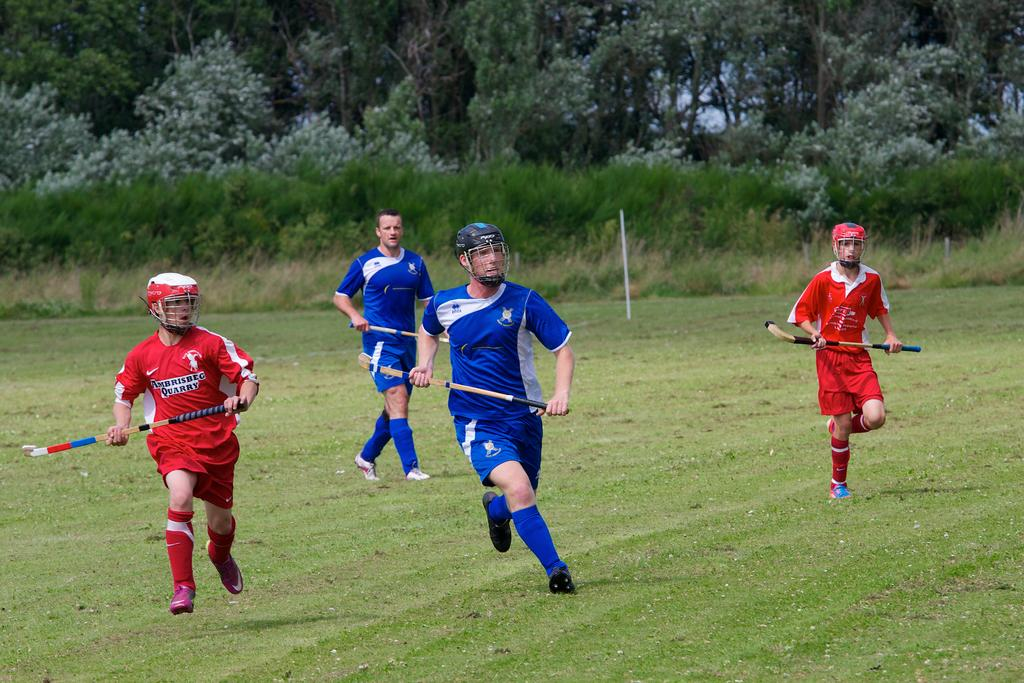<image>
Give a short and clear explanation of the subsequent image. The red team is wearing jerseys from Ambrisbeg. 